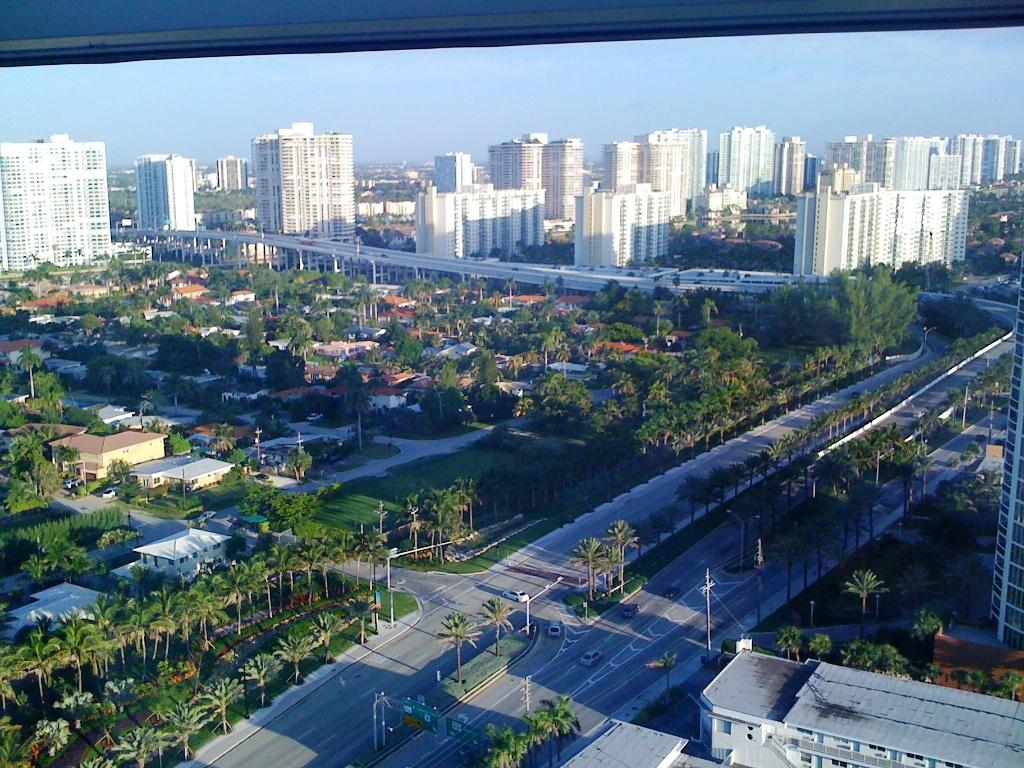What type of vegetation can be seen in the image? There are trees in the image, and they are green. What type of structures are present in the image? There are buildings in the image, and they are white. What color is the sky in the image? The sky is visible in the image, and it is blue. What type of infrastructure can be seen in the image? There are electric poles and light poles in the image. Can you tell me how many snails are crawling on the buildings in the image? There are no snails present in the image; the buildings are white and do not have any snails on them. What emotion is being expressed by the trees in the image? Trees do not express emotions, so this question cannot be answered based on the information provided. 